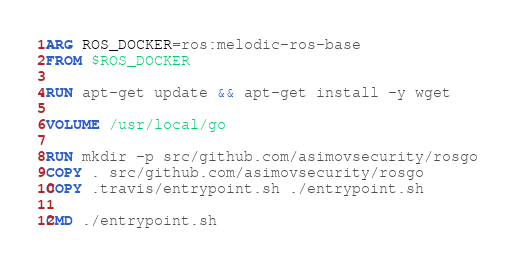Convert code to text. <code><loc_0><loc_0><loc_500><loc_500><_Dockerfile_>ARG ROS_DOCKER=ros:melodic-ros-base
FROM $ROS_DOCKER

RUN apt-get update && apt-get install -y wget

VOLUME /usr/local/go

RUN mkdir -p src/github.com/asimovsecurity/rosgo
COPY . src/github.com/asimovsecurity/rosgo
COPY .travis/entrypoint.sh ./entrypoint.sh

CMD ./entrypoint.sh
</code> 